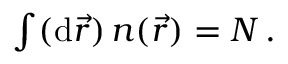<formula> <loc_0><loc_0><loc_500><loc_500>\begin{array} { r } { \int ( d \vec { r } ) \, n ( \vec { r } ) = N \, . } \end{array}</formula> 